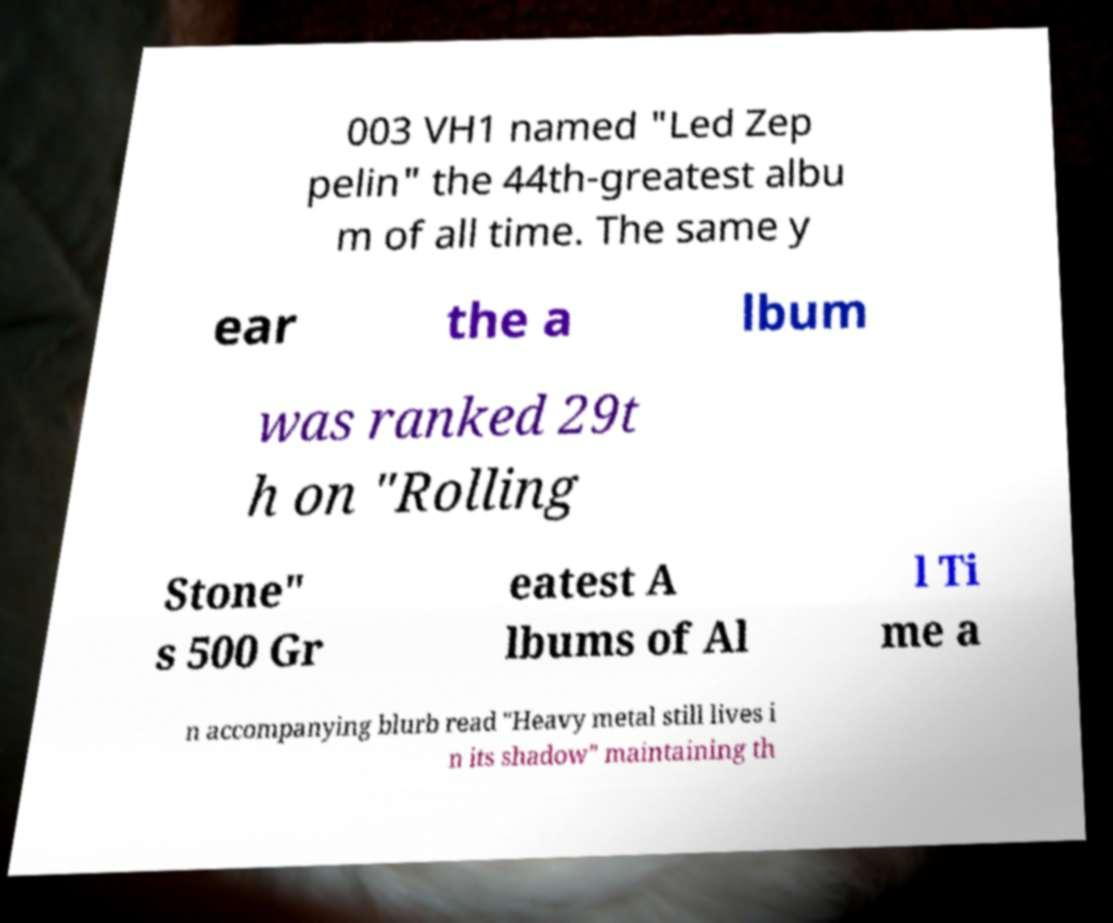Could you assist in decoding the text presented in this image and type it out clearly? 003 VH1 named "Led Zep pelin" the 44th-greatest albu m of all time. The same y ear the a lbum was ranked 29t h on "Rolling Stone" s 500 Gr eatest A lbums of Al l Ti me a n accompanying blurb read "Heavy metal still lives i n its shadow" maintaining th 